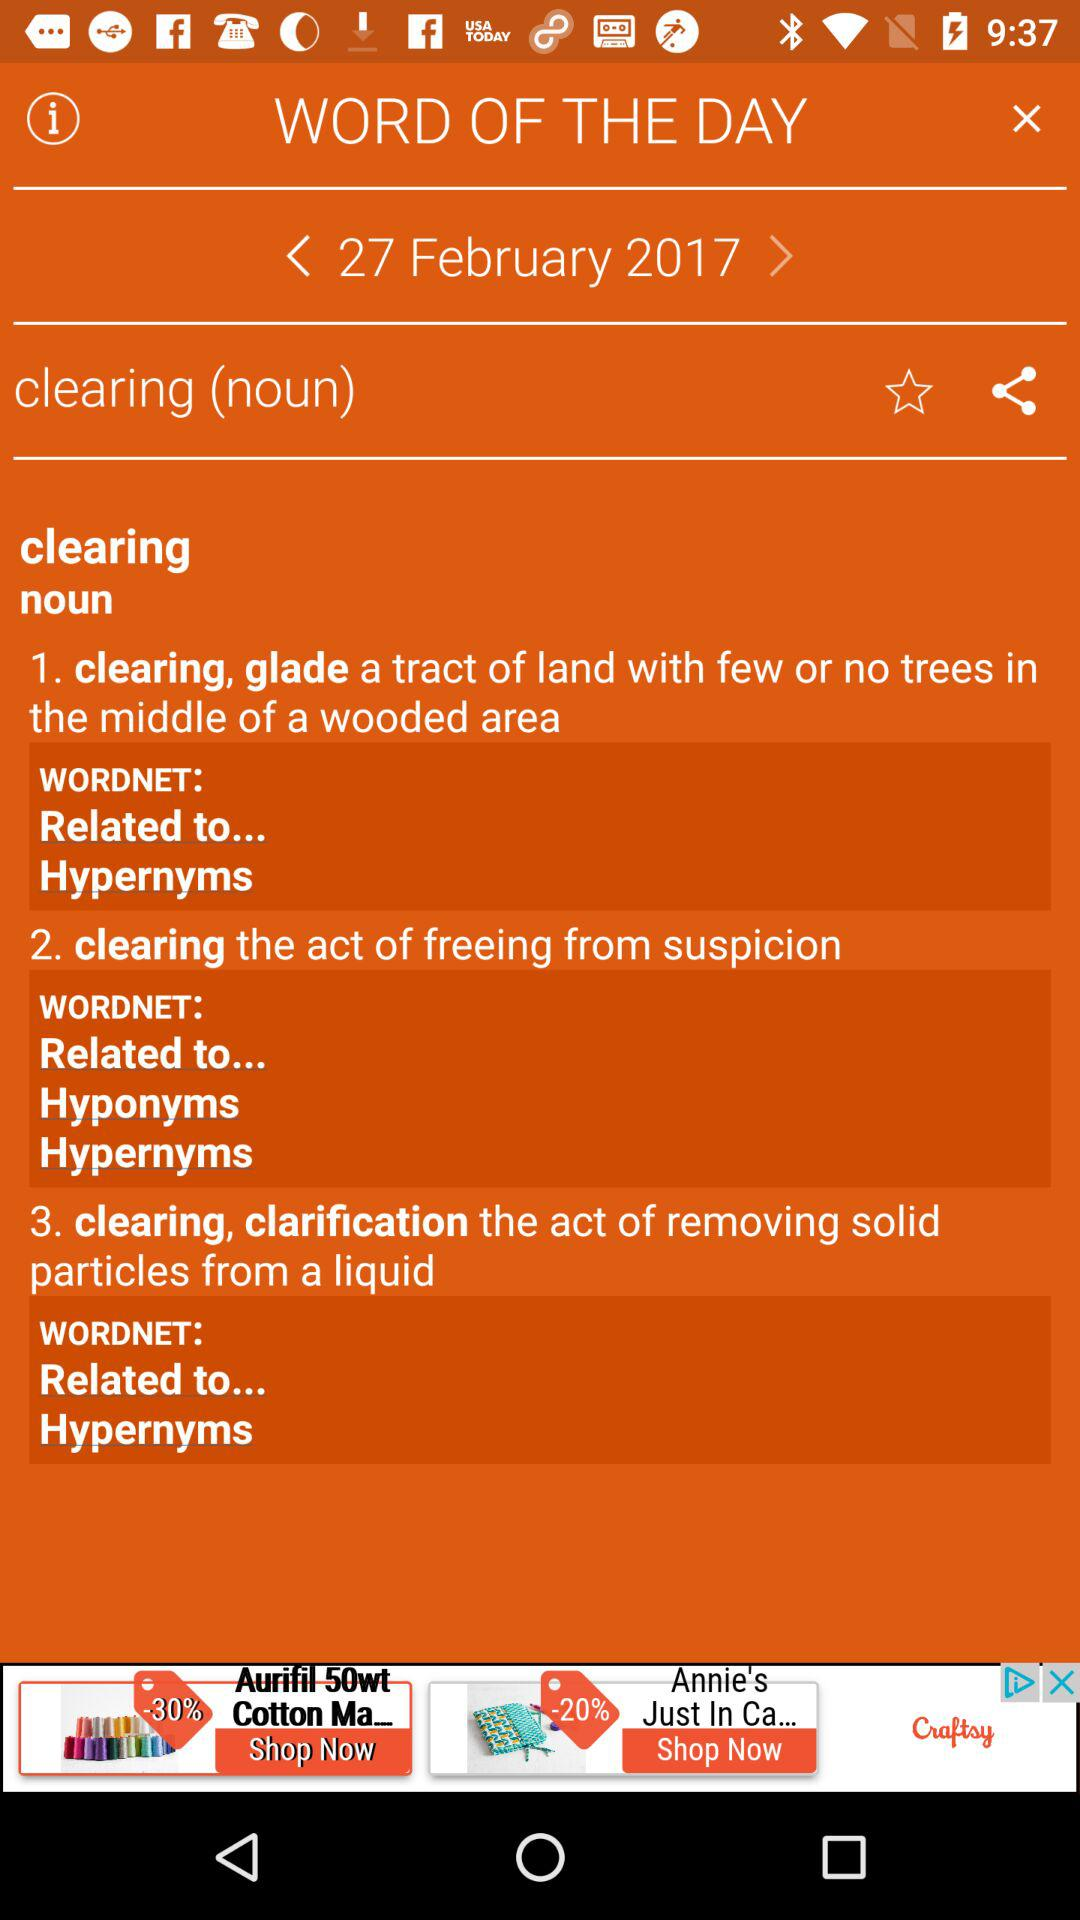What is the word of the day? The word of the day is "clearing". 